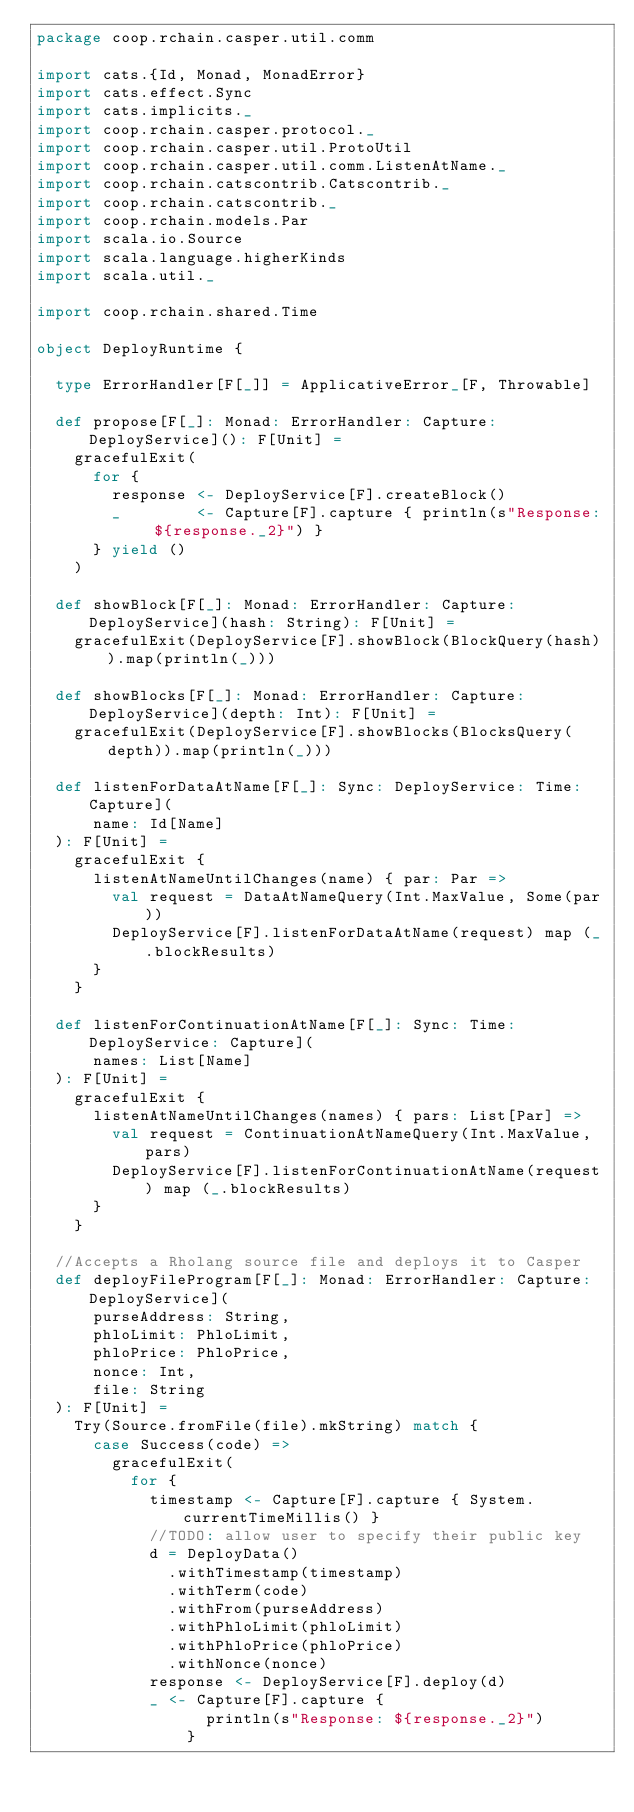<code> <loc_0><loc_0><loc_500><loc_500><_Scala_>package coop.rchain.casper.util.comm

import cats.{Id, Monad, MonadError}
import cats.effect.Sync
import cats.implicits._
import coop.rchain.casper.protocol._
import coop.rchain.casper.util.ProtoUtil
import coop.rchain.casper.util.comm.ListenAtName._
import coop.rchain.catscontrib.Catscontrib._
import coop.rchain.catscontrib._
import coop.rchain.models.Par
import scala.io.Source
import scala.language.higherKinds
import scala.util._

import coop.rchain.shared.Time

object DeployRuntime {

  type ErrorHandler[F[_]] = ApplicativeError_[F, Throwable]

  def propose[F[_]: Monad: ErrorHandler: Capture: DeployService](): F[Unit] =
    gracefulExit(
      for {
        response <- DeployService[F].createBlock()
        _        <- Capture[F].capture { println(s"Response: ${response._2}") }
      } yield ()
    )

  def showBlock[F[_]: Monad: ErrorHandler: Capture: DeployService](hash: String): F[Unit] =
    gracefulExit(DeployService[F].showBlock(BlockQuery(hash)).map(println(_)))

  def showBlocks[F[_]: Monad: ErrorHandler: Capture: DeployService](depth: Int): F[Unit] =
    gracefulExit(DeployService[F].showBlocks(BlocksQuery(depth)).map(println(_)))

  def listenForDataAtName[F[_]: Sync: DeployService: Time: Capture](
      name: Id[Name]
  ): F[Unit] =
    gracefulExit {
      listenAtNameUntilChanges(name) { par: Par =>
        val request = DataAtNameQuery(Int.MaxValue, Some(par))
        DeployService[F].listenForDataAtName(request) map (_.blockResults)
      }
    }

  def listenForContinuationAtName[F[_]: Sync: Time: DeployService: Capture](
      names: List[Name]
  ): F[Unit] =
    gracefulExit {
      listenAtNameUntilChanges(names) { pars: List[Par] =>
        val request = ContinuationAtNameQuery(Int.MaxValue, pars)
        DeployService[F].listenForContinuationAtName(request) map (_.blockResults)
      }
    }

  //Accepts a Rholang source file and deploys it to Casper
  def deployFileProgram[F[_]: Monad: ErrorHandler: Capture: DeployService](
      purseAddress: String,
      phloLimit: PhloLimit,
      phloPrice: PhloPrice,
      nonce: Int,
      file: String
  ): F[Unit] =
    Try(Source.fromFile(file).mkString) match {
      case Success(code) =>
        gracefulExit(
          for {
            timestamp <- Capture[F].capture { System.currentTimeMillis() }
            //TODO: allow user to specify their public key
            d = DeployData()
              .withTimestamp(timestamp)
              .withTerm(code)
              .withFrom(purseAddress)
              .withPhloLimit(phloLimit)
              .withPhloPrice(phloPrice)
              .withNonce(nonce)
            response <- DeployService[F].deploy(d)
            _ <- Capture[F].capture {
                  println(s"Response: ${response._2}")
                }</code> 